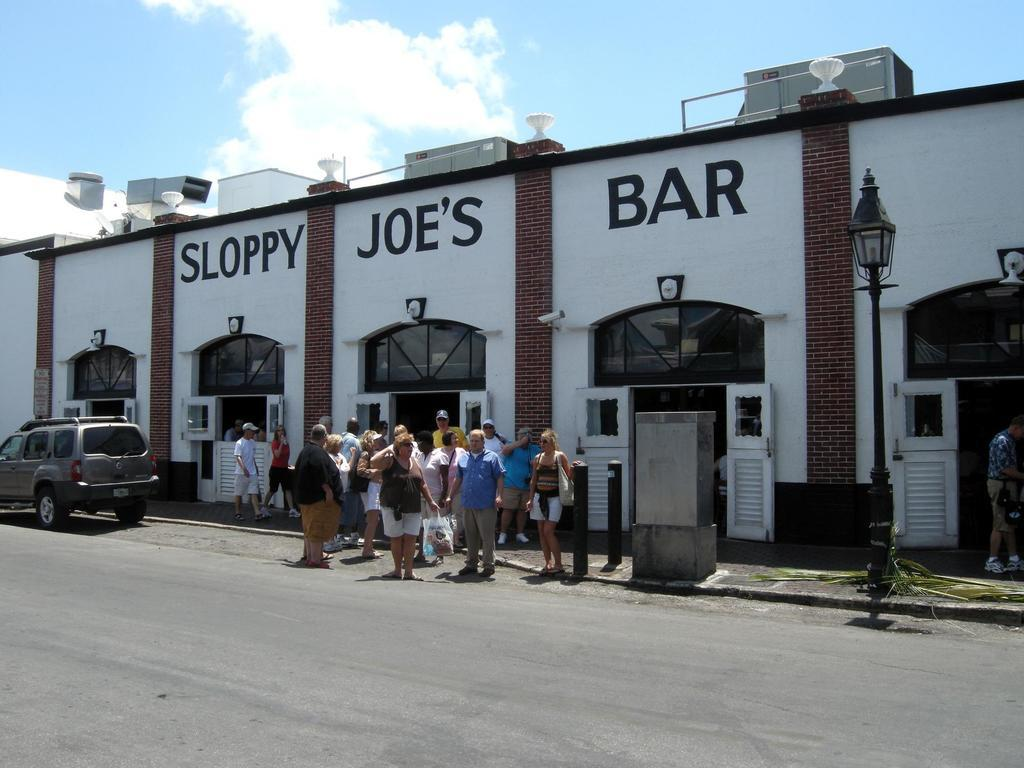What type of structures can be seen in the image? There are buildings in the image. What feature is common to many of the buildings? There are doors in the image. What type of lighting is present in the image? There is a street lamp in the image. Are there any living beings visible in the image? Yes, there are people visible in the image. What can be seen in the background of the image? The sky is visible in the image, and clouds are present in the sky. What type of swing can be seen in the image? There is no swing present in the image. What type of jewelry is the person wearing in the image? There is no jewelry visible in the image. What celestial body is visible in the image? The moon is not visible in the image; only the sky and clouds are present. 